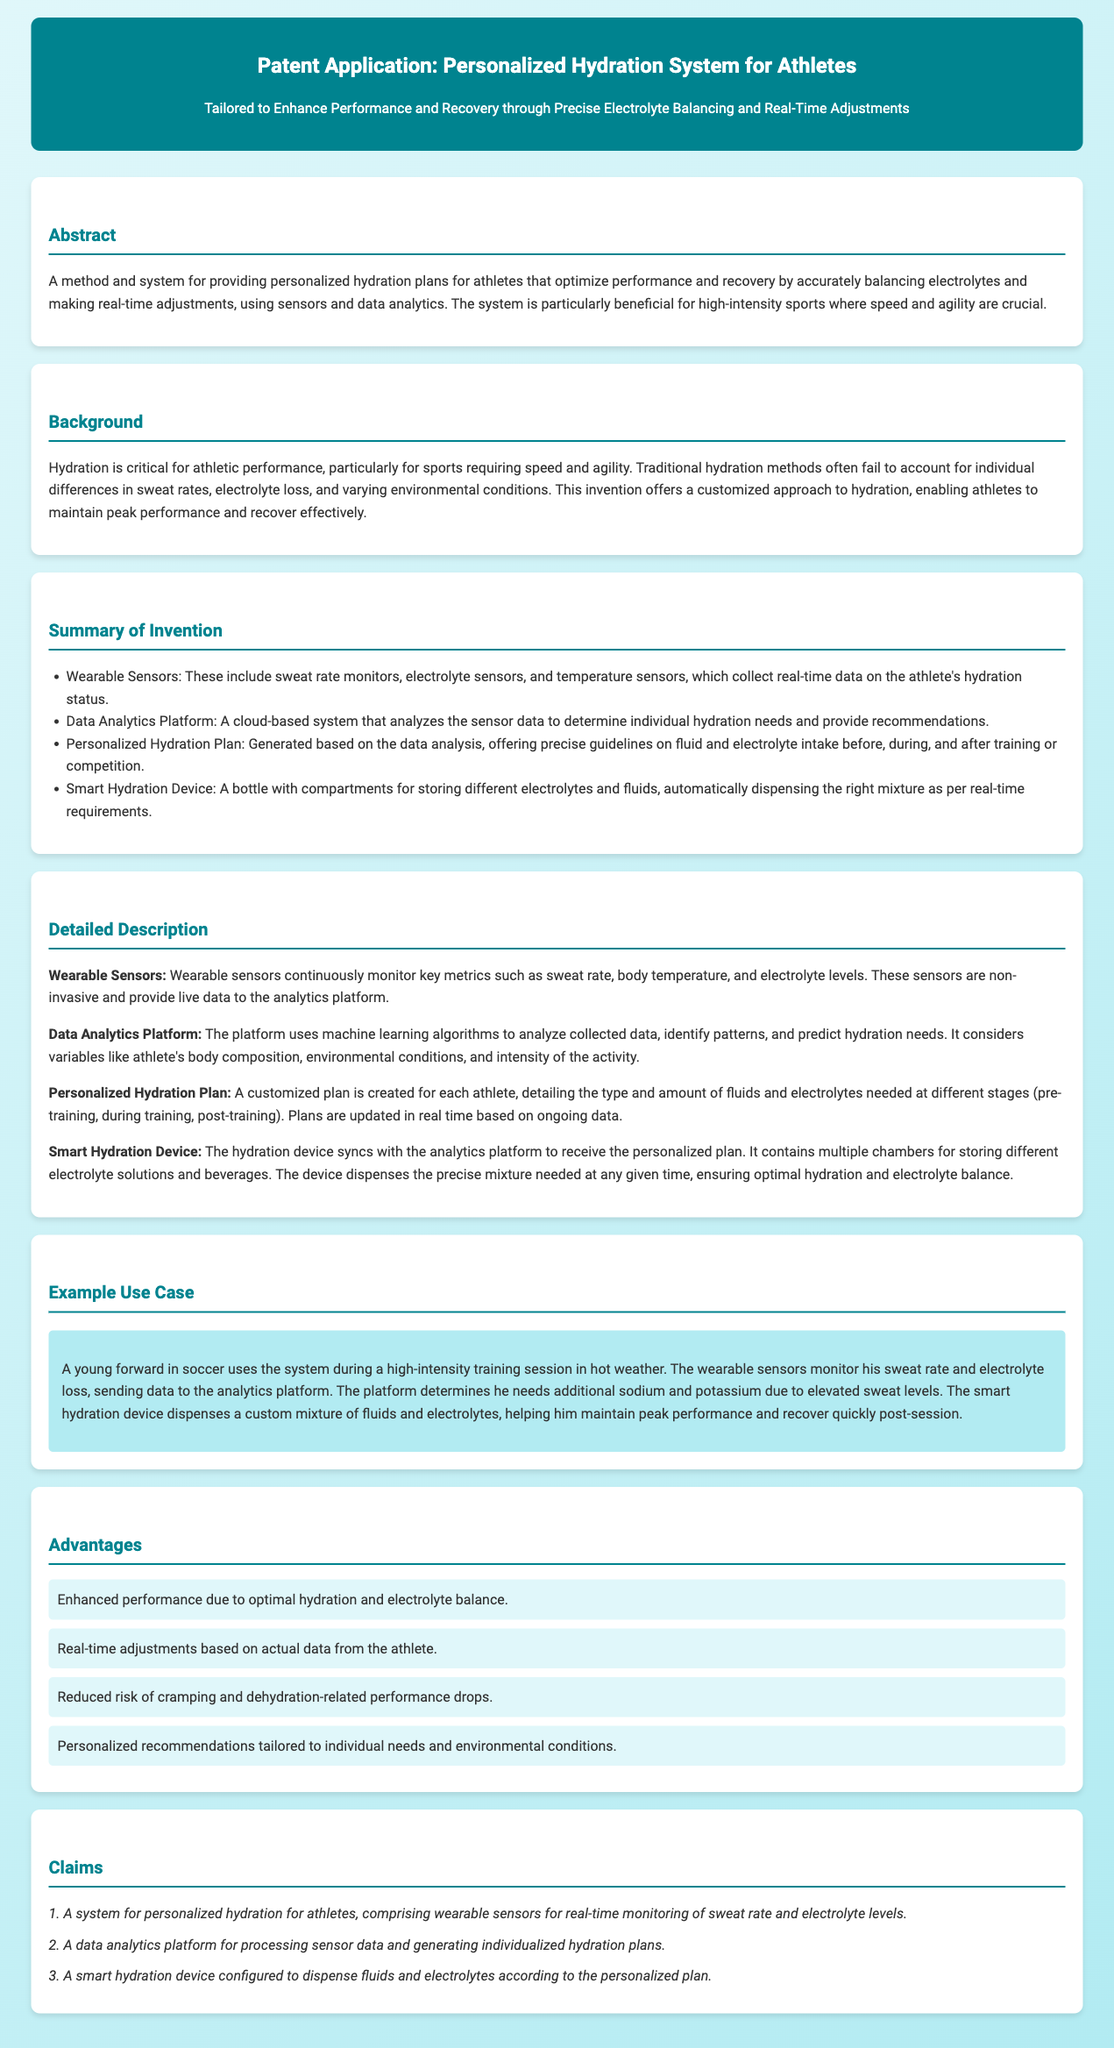What is the title of the patent application? The title is stated in the header of the document, which describes the main subject matter of the application.
Answer: Personalized Hydration System for Athletes What type of technology is used to monitor hydration status? The document specifies wearable sensors as the technology for monitoring.
Answer: Wearable Sensors What are the key metrics monitored by the wearable sensors? The detailed description mentions key metrics such as sweat rate, body temperature, and electrolyte levels.
Answer: Sweat rate, body temperature, and electrolyte levels What does the data analytics platform use to predict hydration needs? The document explains that the platform uses machine learning algorithms to analyze the collected data for predictions.
Answer: Machine learning algorithms How does the smart hydration device operate? The detailed description explains that it dispenses the precise mixture needed based on data received from the analytics platform.
Answer: Dispenses the precise mixture needed What is a significant advantage of the personalized hydration system? The advantages section lists multiple benefits, including optimal hydration and electrolyte balance.
Answer: Enhanced performance due to optimal hydration and electrolyte balance What is one specific use case mentioned for the system? The example use case details a young forward using the system during a high-intensity training session.
Answer: Young forward in soccer during a high-intensity training session What type of document is this? The patent application clearly indicates itself as a type related to the legal protection of an invention.
Answer: Patent Application 